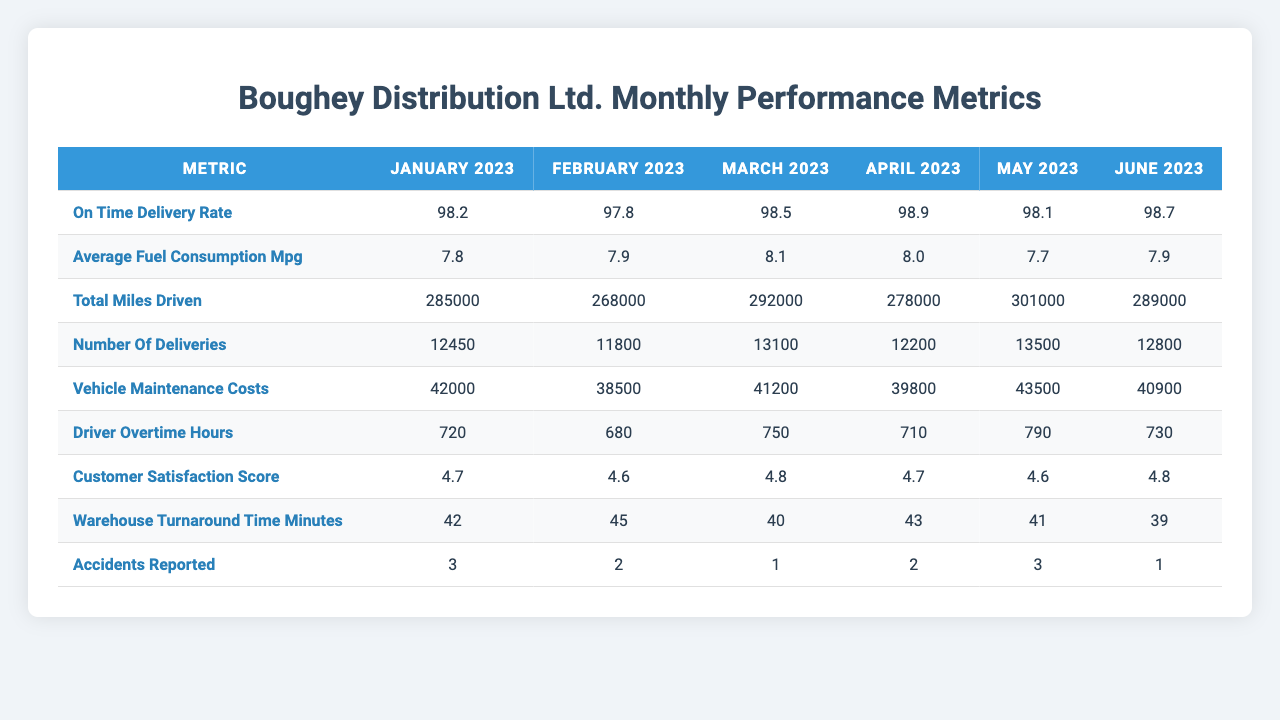What is the on-time delivery rate for May 2023? The table shows the on-time delivery rate for each month, and for May 2023, the value is found directly in the corresponding cell.
Answer: 98.1 Which month had the highest total miles driven? By comparing the values in the total miles driven row, I found that the maximum value for total miles driven is 301000, which corresponds to May 2023.
Answer: May 2023 What was the average customer satisfaction score for the first quarter of 2023 (January, February, March)? The scores for the first quarter are 4.7 (January), 4.6 (February), and 4.8 (March). To find the average, I sum the three scores (4.7 + 4.6 + 4.8 = 14.1) and divide by 3, giving an average score of 4.7.
Answer: 4.7 Is the average fuel consumption in June 2023 higher than in January 2023? The average fuel consumption in June 2023 is 7.9 mpg, and in January 2023, it is 7.8 mpg. Comparing these values, June 2023 is higher.
Answer: Yes How many accidents were reported in total over the six months? To find the total number of accidents, I must sum up all reported accidents across the six months: (3 + 2 + 1 + 2 + 3 + 1 = 12).
Answer: 12 What was the percentage change in the number of deliveries from January 2023 to April 2023? The number of deliveries increased from 12450 in January 2023 to 12200 in April 2023. The percentage change is calculated as [(12200 - 12450) / 12450] * 100 = -2.01%.
Answer: -2.01% What is the trend in driver overtime hours from January to June 2023? By examining the data in the driver overtime hours row, I see values of 720, 680, 750, 710, 790, and 730. The overall trend shows a peak in May (790) before decreasing in June (730) after fluctuating in the prior months.
Answer: Fluctuating, with a peak in May What is the average vehicle maintenance cost for the last three months (April, May, June)? The vehicle maintenance costs for April, May, and June are 39800, 43500, and 40900, respectively. I sum these amounts (39800 + 43500 + 40900 = 124200) and divide by 3 to find an average of 41400.
Answer: 41400 Which month had the lowest warehouse turnaround time? I compare the warehouse turnaround times in the respective row: 42 (January), 45 (February), 40 (March), 43 (April), 41 (May), and 39 (June). The lowest value is 39, corresponding to June 2023.
Answer: June 2023 Was the on-time delivery rate consistent across the six months? By analyzing the on-time delivery rates, I see values varying between 97.8 and 98.9. The values demonstrate fluctuations, indicating inconsistency throughout the period.
Answer: No 